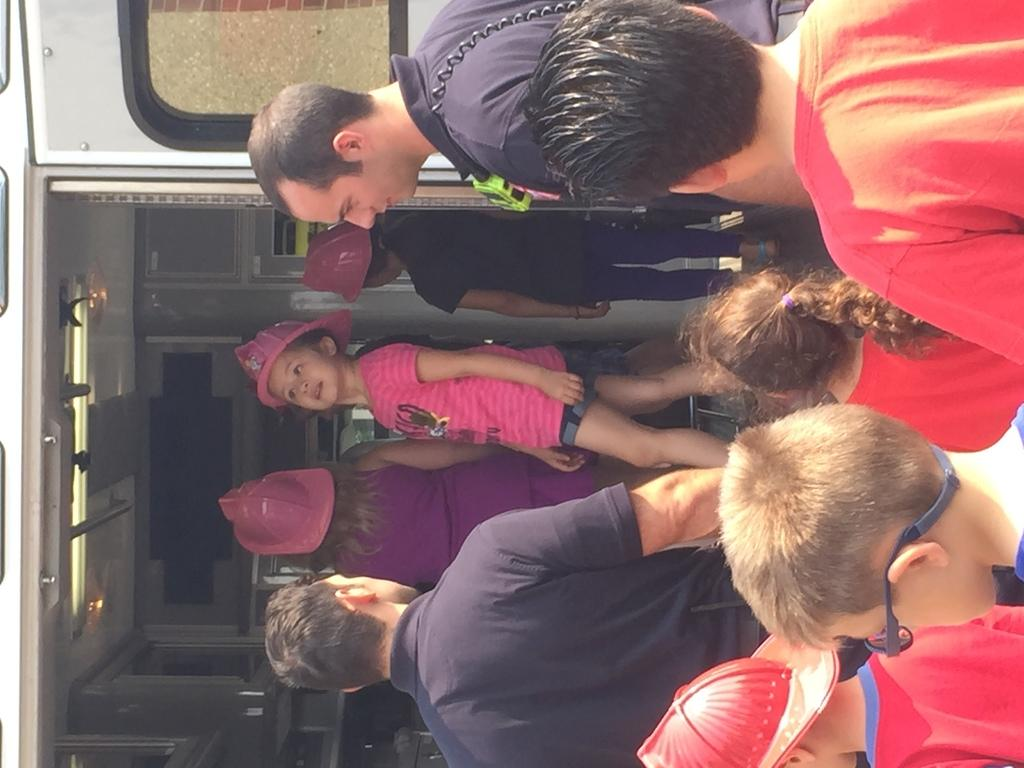How many people are in the image? There are two men and children in the image. Can you describe the vehicle in the image? There is a vehicle on the left side of the image. How many girls are in the vehicle? There are three girls in the vehicle. What type of milk can be seen in the library in the image? There is no library or milk present in the image. What type of tank is visible in the image? There is no tank present in the image. 